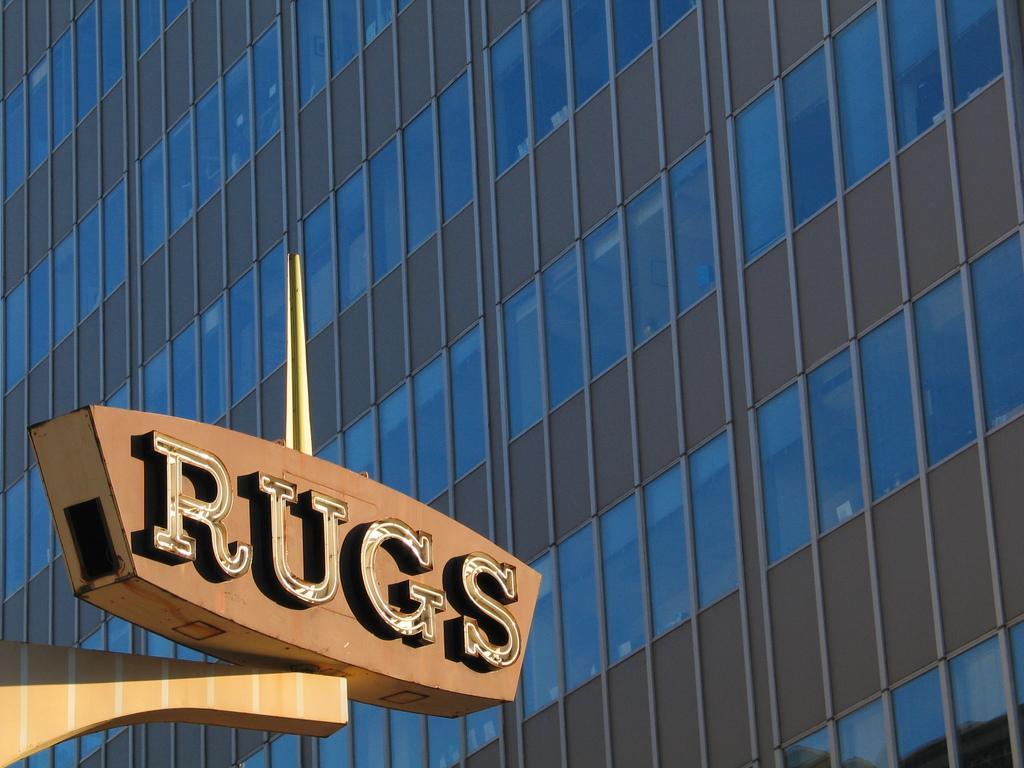How would you summarize this image in a sentence or two? In this picture I can see the building with glass windows on the right side. I can see the board on the left side. 